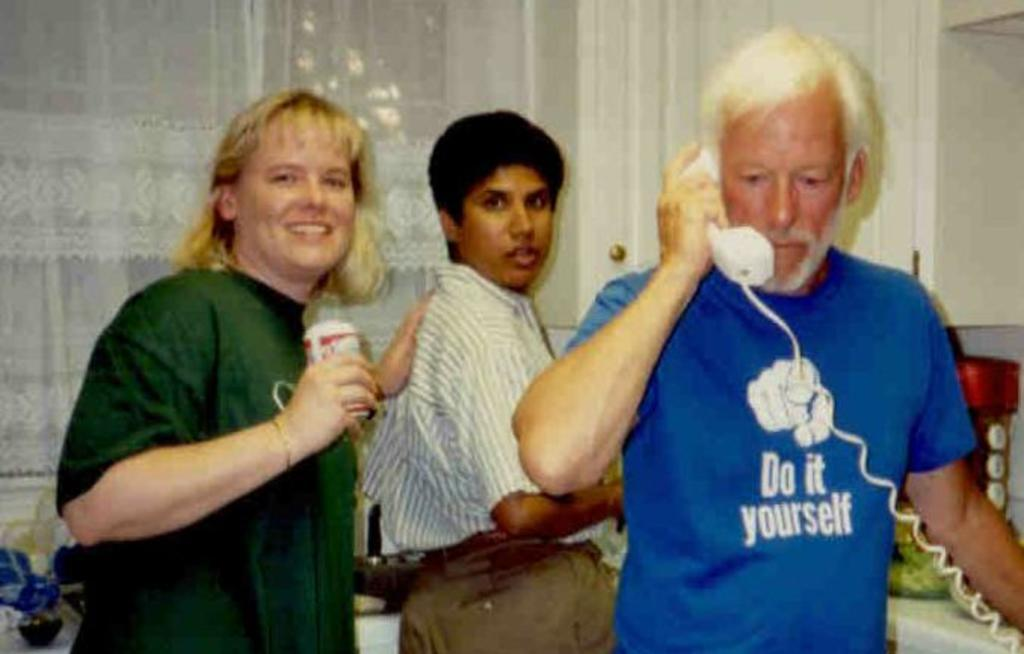How many people are in the image? There are three people in the image. Can you describe the position of the man on the right side of the image? The man is standing on the right side of the image. What is the man wearing? The man is wearing a blue t-shirt. What is the man holding in the image? The man is holding a telephone. What type of shoe is the fireman wearing in the image? There is no fireman present in the image, and therefore no shoes to describe. 